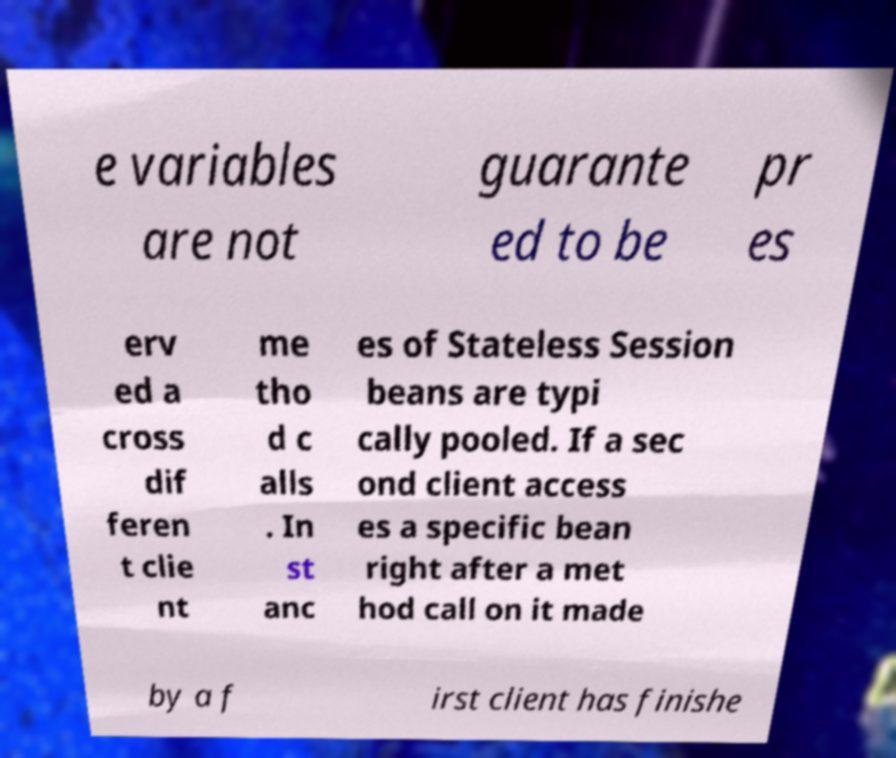For documentation purposes, I need the text within this image transcribed. Could you provide that? e variables are not guarante ed to be pr es erv ed a cross dif feren t clie nt me tho d c alls . In st anc es of Stateless Session beans are typi cally pooled. If a sec ond client access es a specific bean right after a met hod call on it made by a f irst client has finishe 